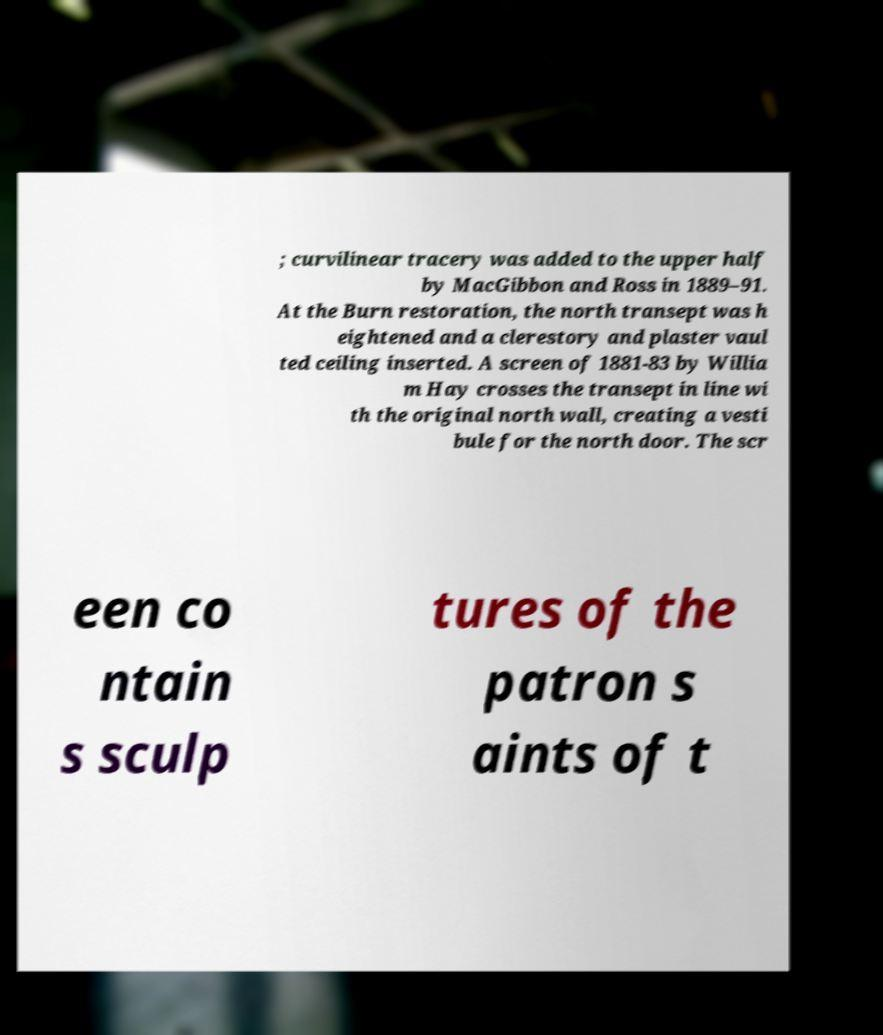Could you assist in decoding the text presented in this image and type it out clearly? ; curvilinear tracery was added to the upper half by MacGibbon and Ross in 1889–91. At the Burn restoration, the north transept was h eightened and a clerestory and plaster vaul ted ceiling inserted. A screen of 1881-83 by Willia m Hay crosses the transept in line wi th the original north wall, creating a vesti bule for the north door. The scr een co ntain s sculp tures of the patron s aints of t 